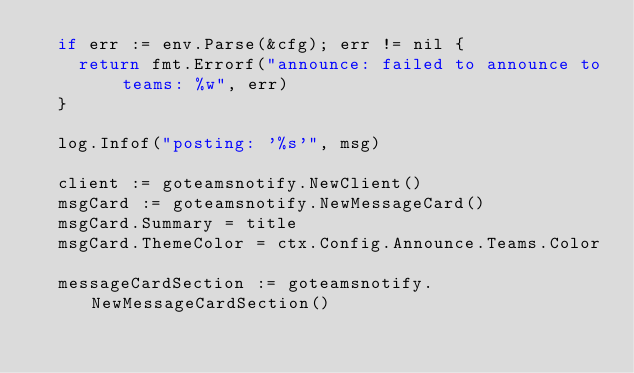Convert code to text. <code><loc_0><loc_0><loc_500><loc_500><_Go_>	if err := env.Parse(&cfg); err != nil {
		return fmt.Errorf("announce: failed to announce to teams: %w", err)
	}

	log.Infof("posting: '%s'", msg)

	client := goteamsnotify.NewClient()
	msgCard := goteamsnotify.NewMessageCard()
	msgCard.Summary = title
	msgCard.ThemeColor = ctx.Config.Announce.Teams.Color

	messageCardSection := goteamsnotify.NewMessageCardSection()</code> 